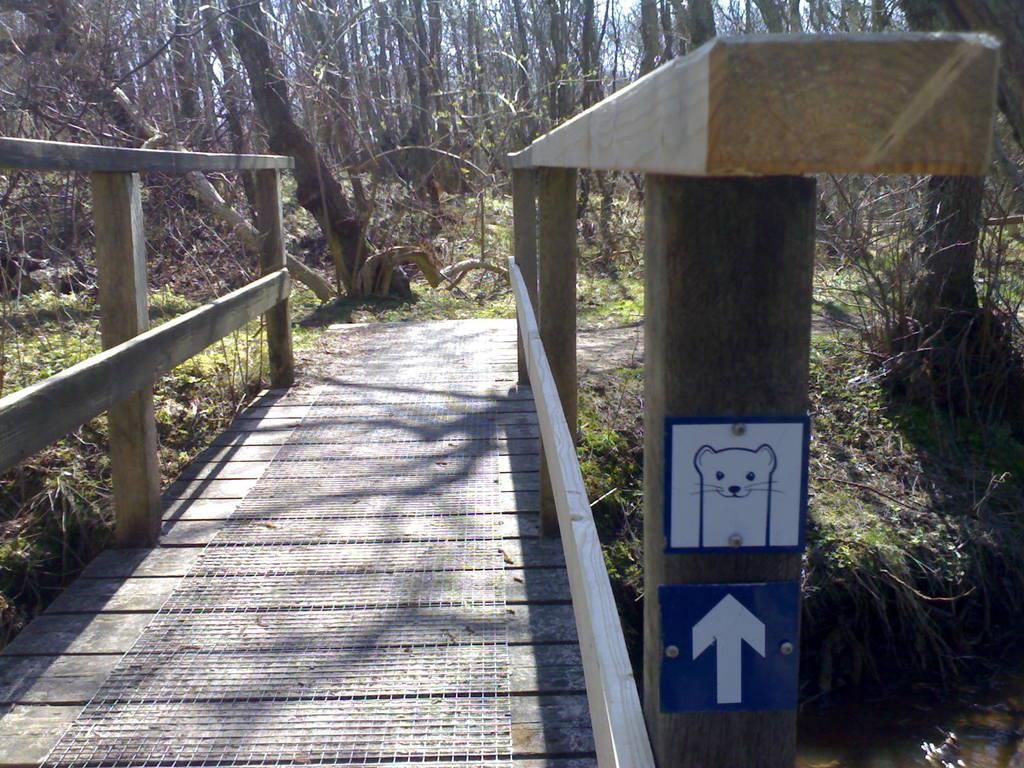What type of structure is present in the image? There is a wooden bridge in the image. Are there any signs or notices on the wooden bridge? Yes, sign boards are attached to the wooden bridge. What can be seen in the background of the image? There are trees and grass visible in the background of the image. What type of jar is being used to protect the wooden bridge from the rainstorm in the image? There is no jar or rainstorm present in the image. The wooden bridge is not being protected by a jar in the image. 